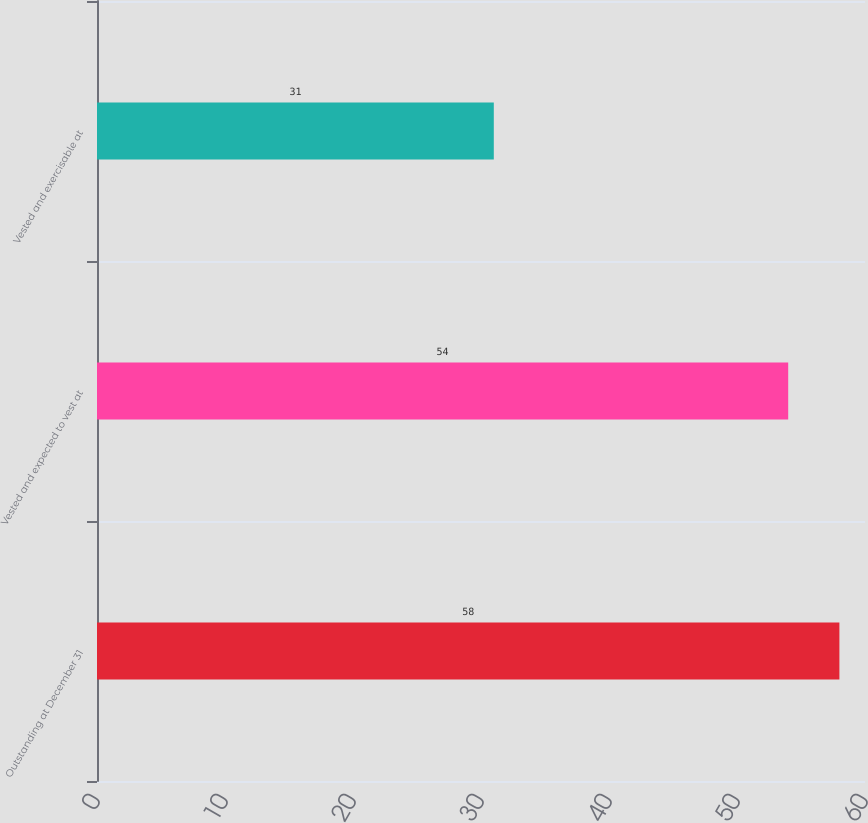Convert chart. <chart><loc_0><loc_0><loc_500><loc_500><bar_chart><fcel>Outstanding at December 31<fcel>Vested and expected to vest at<fcel>Vested and exercisable at<nl><fcel>58<fcel>54<fcel>31<nl></chart> 